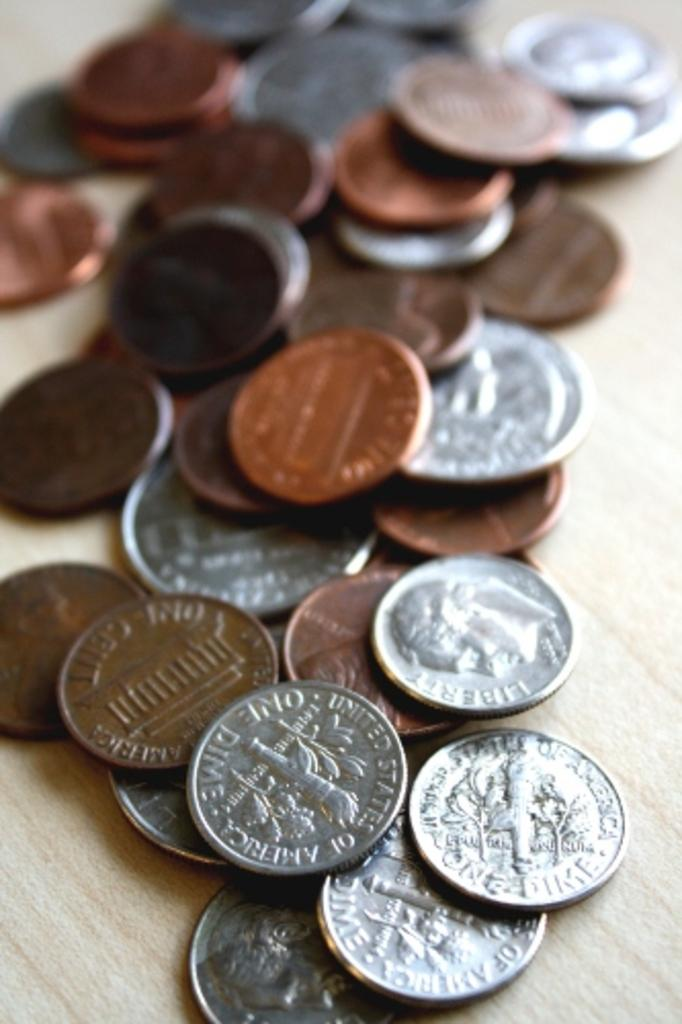<image>
Share a concise interpretation of the image provided. many American coins spilled out on a table like One Dime and One Cent 